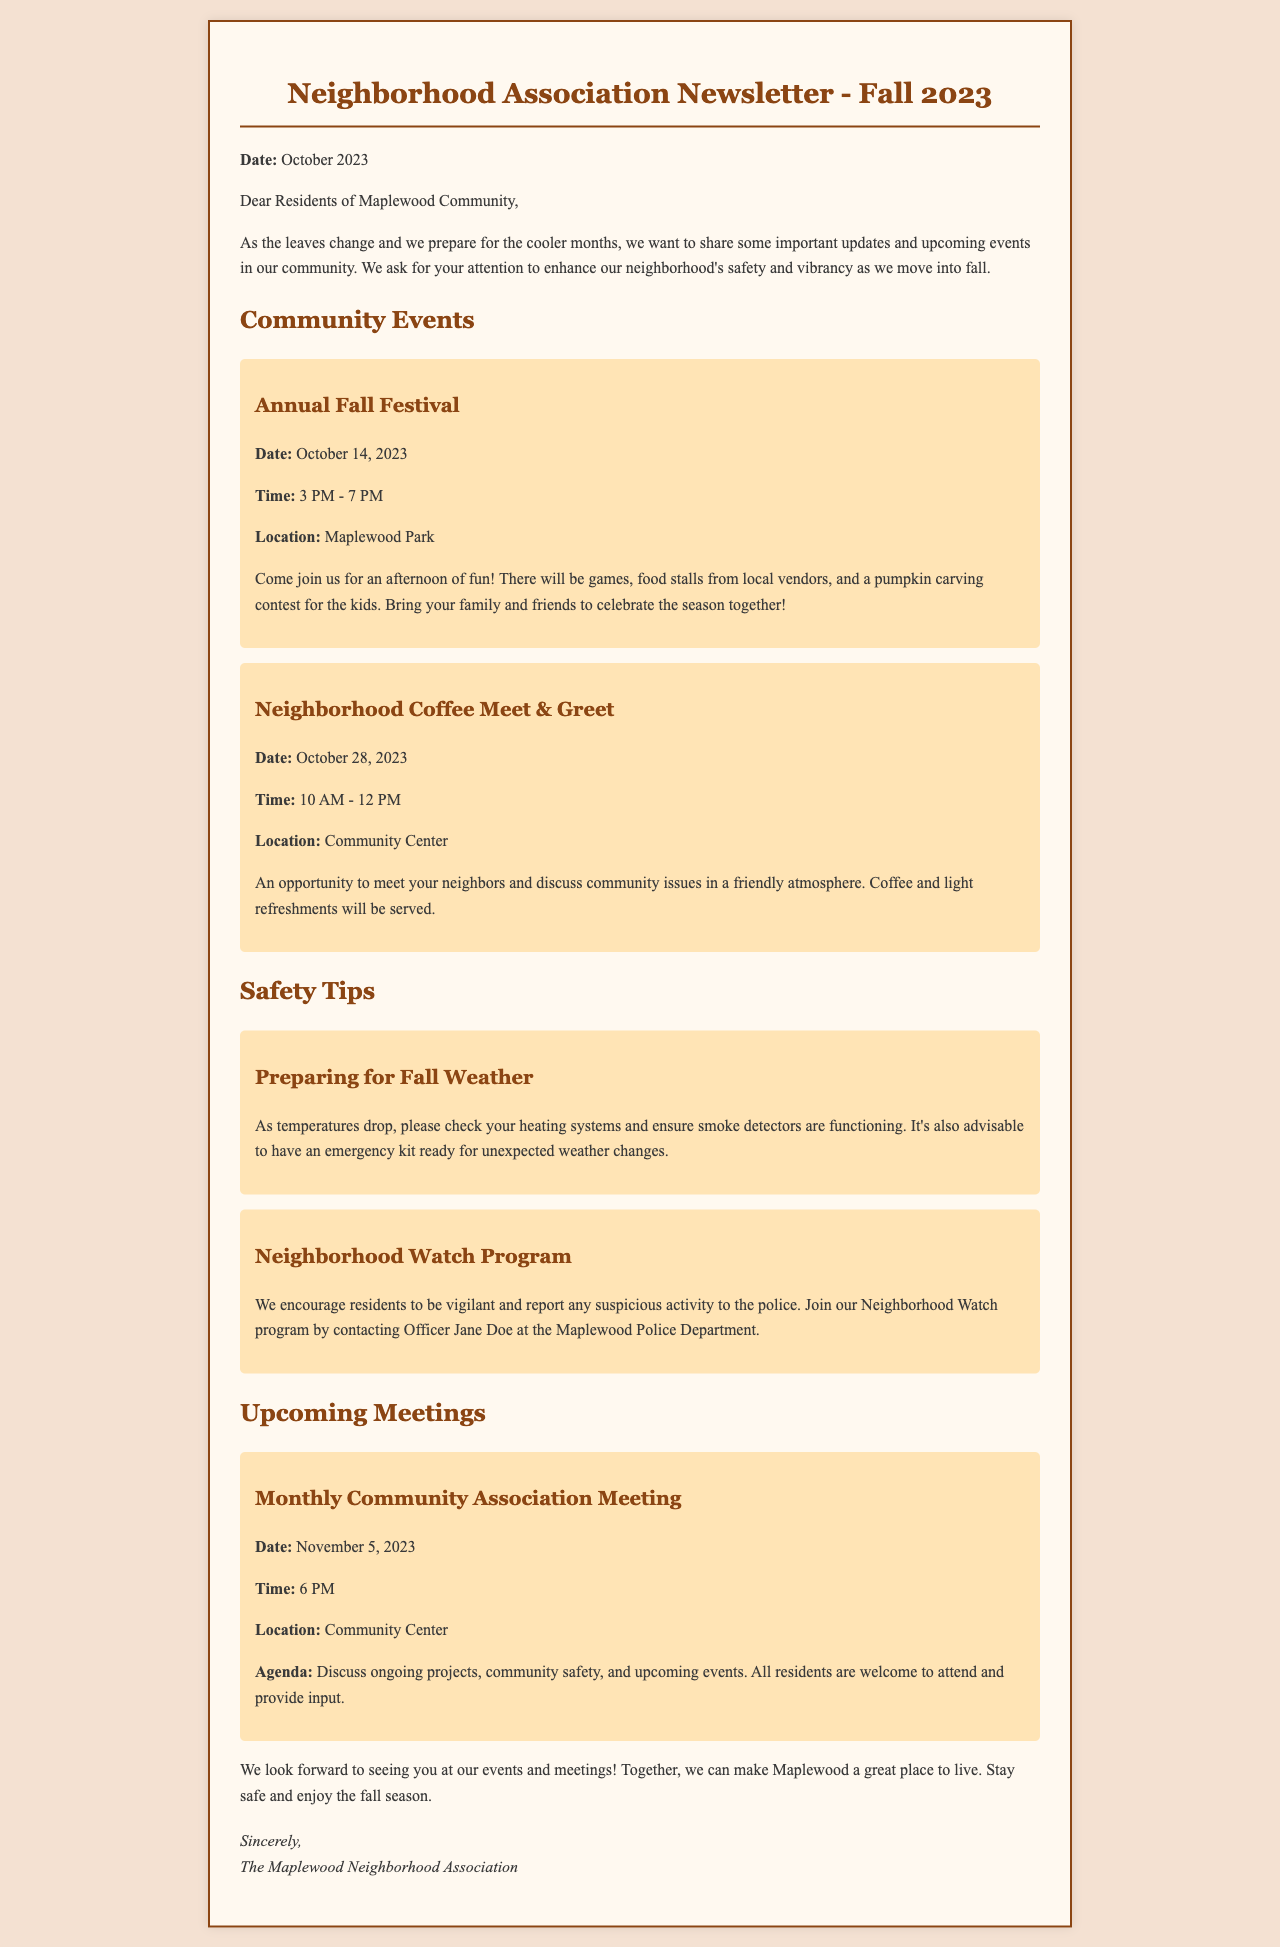What is the date of the Annual Fall Festival? The date is explicitly mentioned in the document under community events.
Answer: October 14, 2023 What time does the Neighborhood Coffee Meet & Greet start? The start time is specified in the event details.
Answer: 10 AM Where will the Monthly Community Association Meeting be held? This information is provided under the upcoming meetings section.
Answer: Community Center What is one of the safety tips mentioned in the newsletter? The newsletter lists safety tips, and one is related to fall weather preparations.
Answer: Preparing for Fall Weather How often does the Community Association Meeting occur? The regularity of the meeting can be inferred from the mention of “Monthly.”
Answer: Monthly Who should you contact to join the Neighborhood Watch program? The document specifically states who to contact for this program.
Answer: Officer Jane Doe What activities will be present at the Annual Fall Festival? The document enumerates several activities in the description of the festival event.
Answer: Games, food stalls, pumpkin carving contest When is the next Neighborhood Association Meeting scheduled? The meeting date is clearly outlined in the upcoming meetings section.
Answer: November 5, 2023 